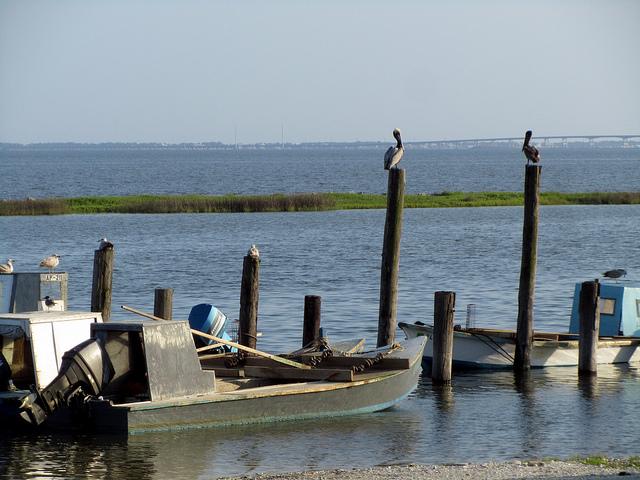Which boat is moving?
Be succinct. None. How many birds are pictured?
Concise answer only. 6. What are majority of birds on?
Be succinct. Posts. 